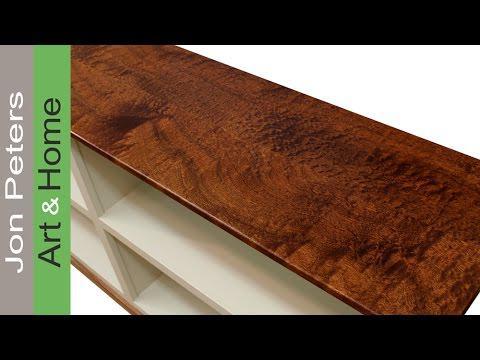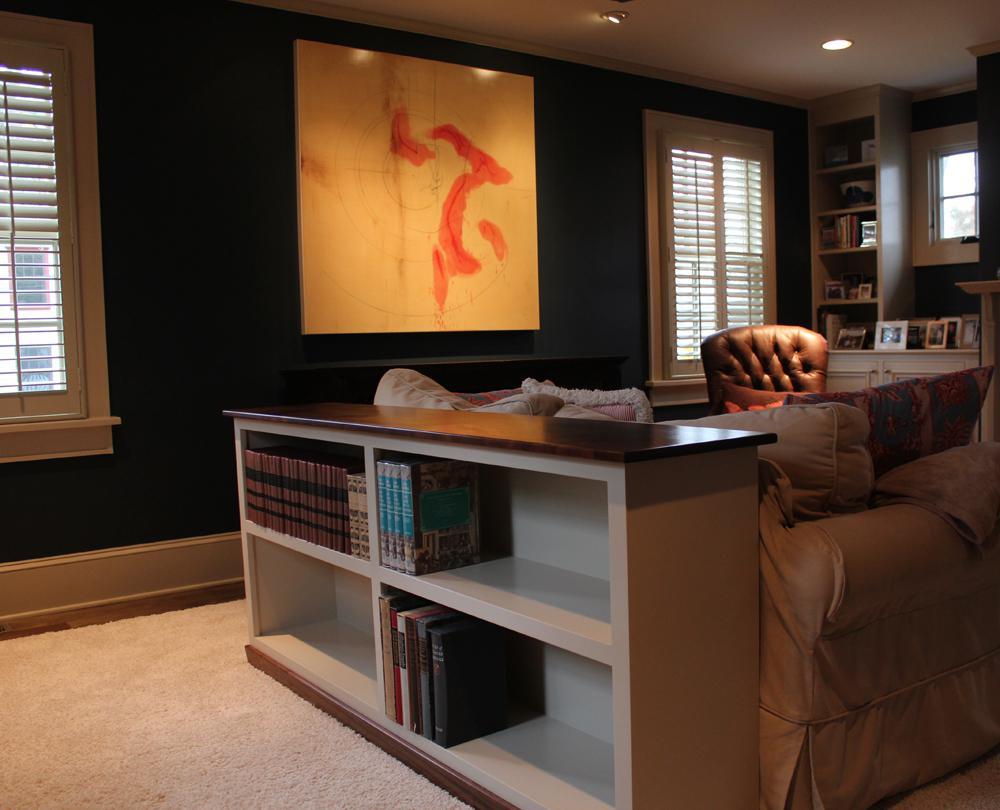The first image is the image on the left, the second image is the image on the right. Given the left and right images, does the statement "In the right image the bookshelf has four different shelves with the bottom left shelf being empty." hold true? Answer yes or no. Yes. The first image is the image on the left, the second image is the image on the right. Evaluate the accuracy of this statement regarding the images: "There is a 4 cubby bookshelf up against a sofa back with books in the shelf". Is it true? Answer yes or no. Yes. 